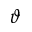<formula> <loc_0><loc_0><loc_500><loc_500>\vartheta</formula> 